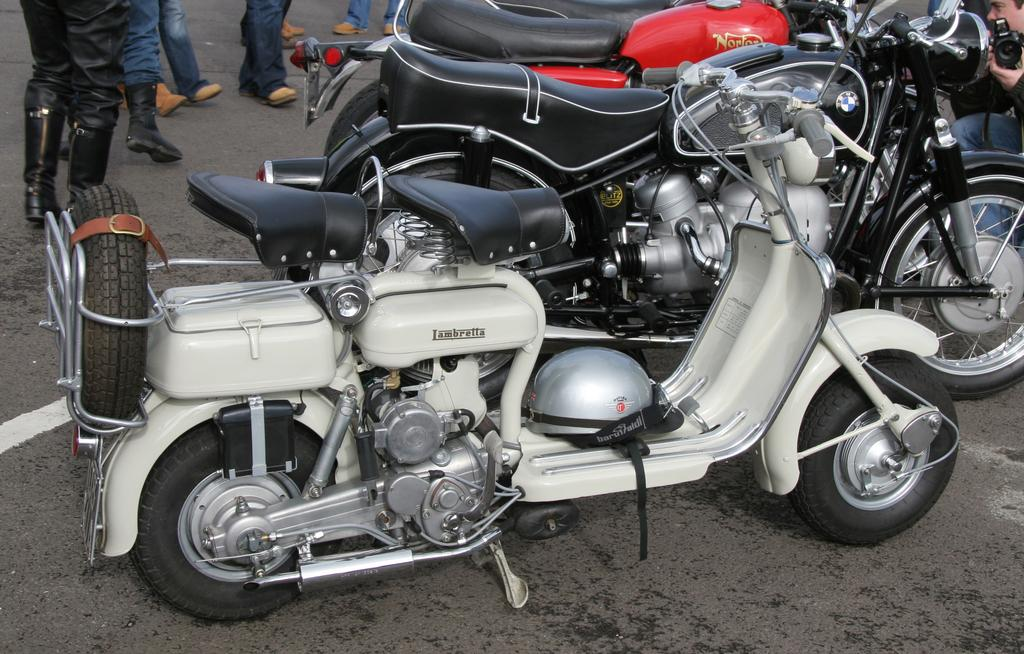What type of vehicles are on the road in the image? There are bikes on the road in the image. What are the people behind the bikes doing? There are people standing on the road behind the bikes. Where is the person holding the camera located in the image? The person holding the camera is on the right side of the image. What type of meat is being grilled on the side of the road in the image? There is no meat or grill present in the image; it only features bikes, people, and a person holding the camera. 